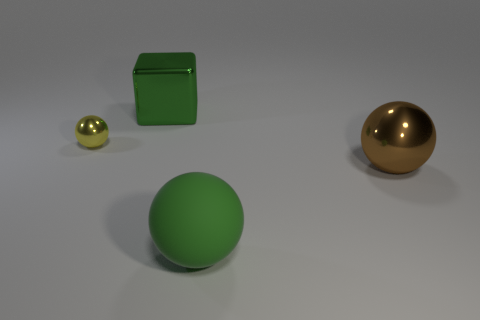Which object in the image looks most different from the others? The green cubic metal container appears most distinct because, unlike the two spheres, it has edges and flat surfaces, giving it a cubic shape. 